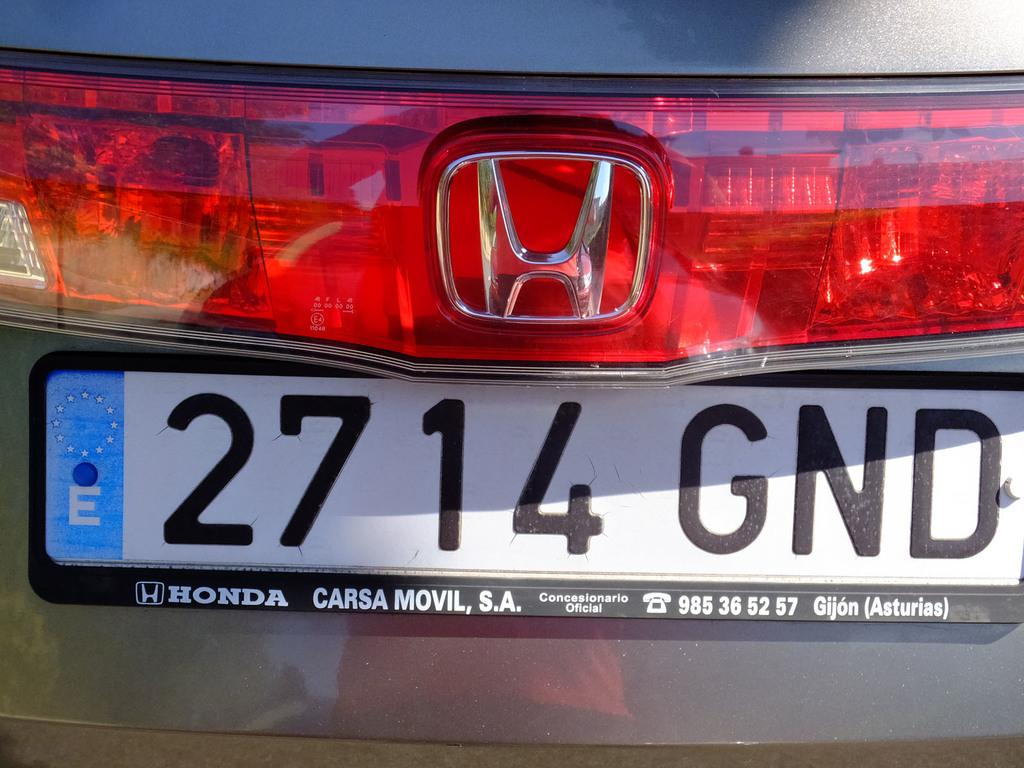Provide a one-sentence caption for the provided image. A Honda has a license plate that reads 2714 GND. 